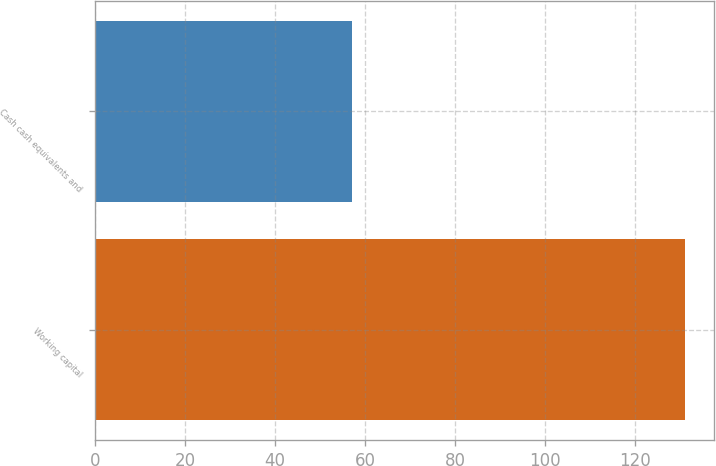Convert chart. <chart><loc_0><loc_0><loc_500><loc_500><bar_chart><fcel>Working capital<fcel>Cash cash equivalents and<nl><fcel>131<fcel>57<nl></chart> 